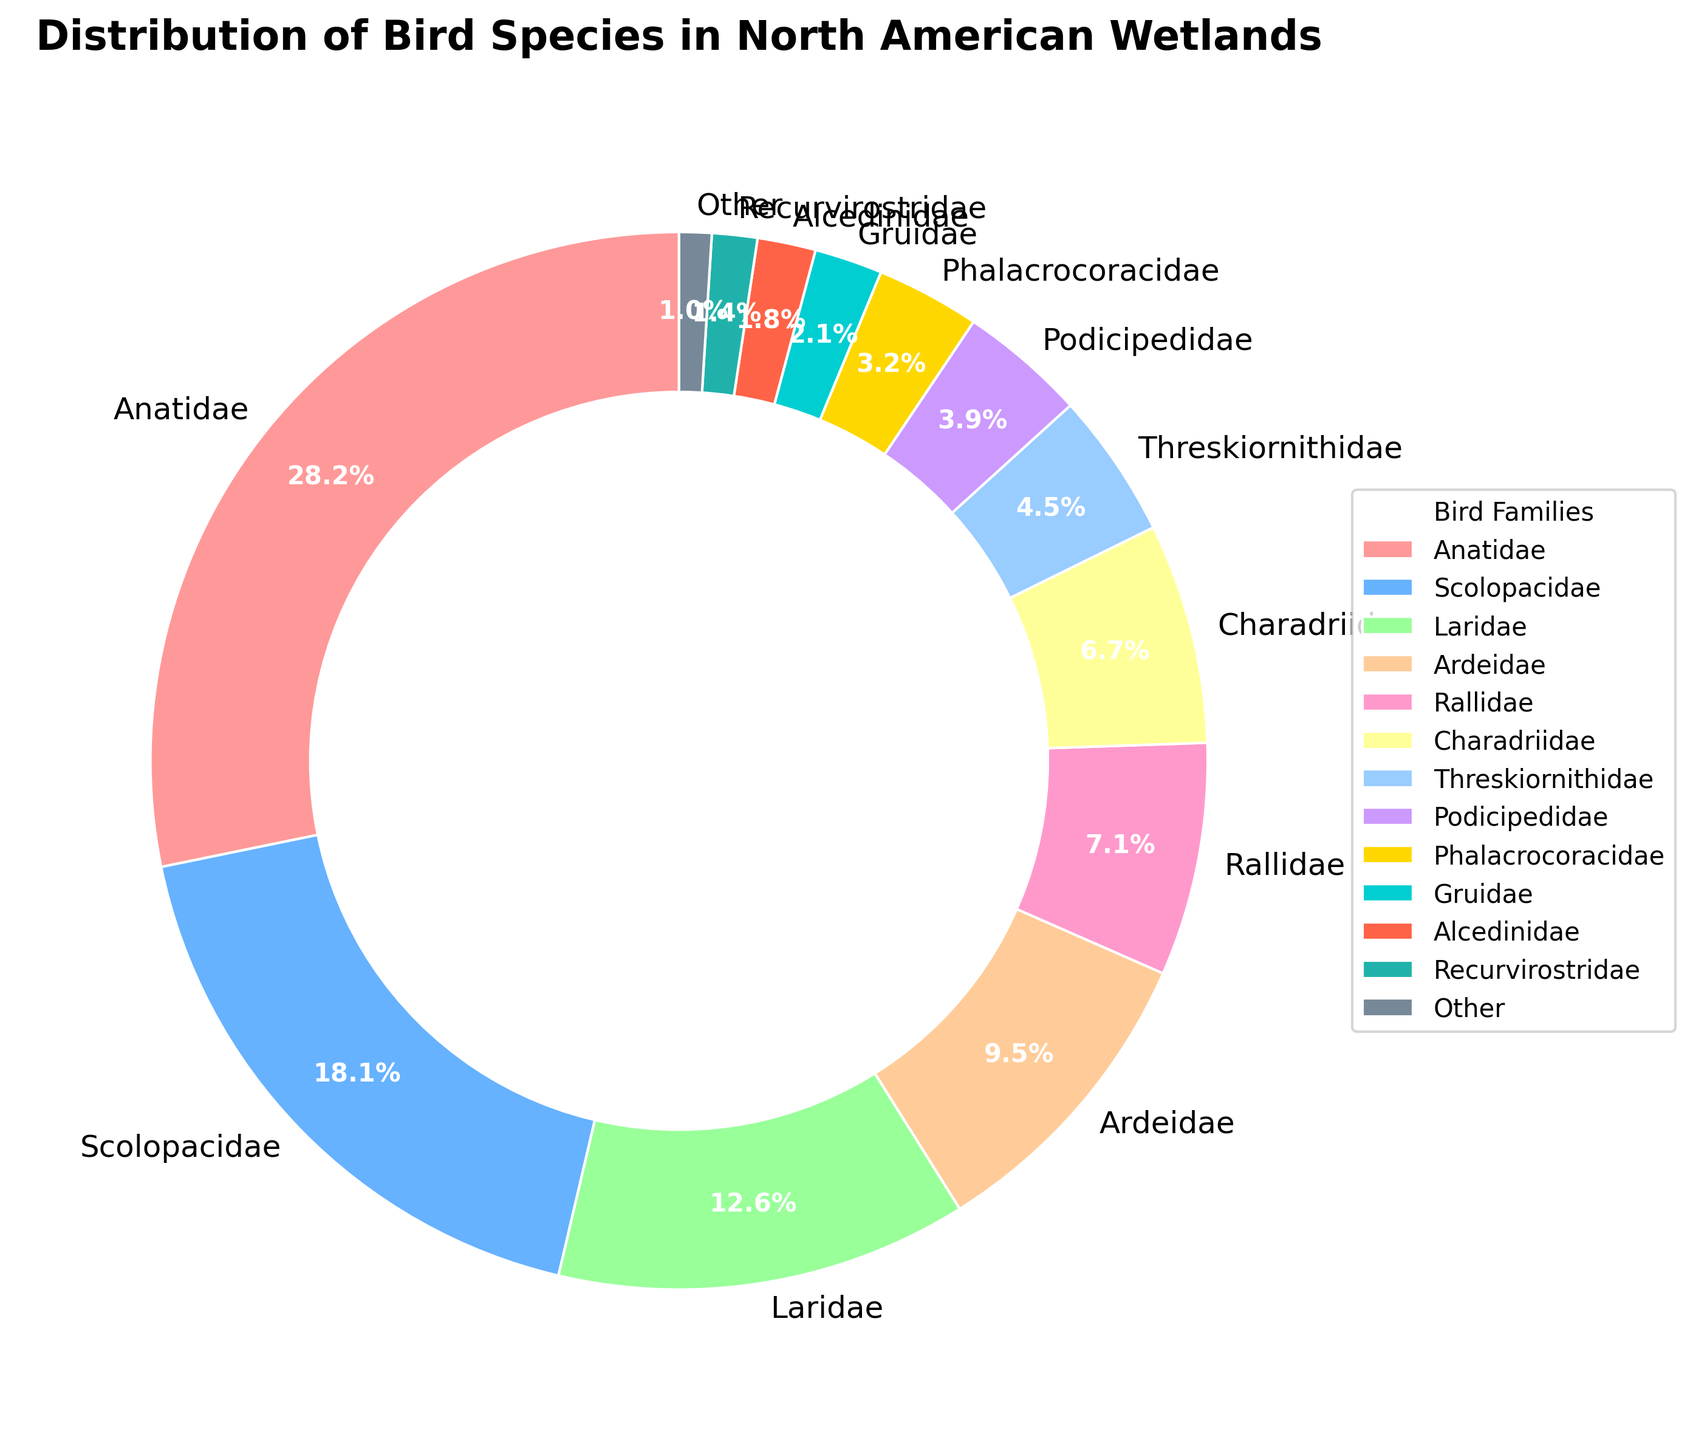What's the largest family of bird species in North American wetlands based on the chart? The chart shows various families and their respective percentages. The family with the highest percentage represents the largest family. The Anatidae family has the highest value of 28.5%.
Answer: Anatidae What's the combined percentage of bird species for the Ardeidae and Rallidae families? The chart lists the percentages for Ardeidae and Rallidae as 9.6% and 7.2%, respectively. Adding these percentages together gives a total of 9.6% + 7.2% = 16.8%.
Answer: 16.8% Which family has a higher percentage of bird species: Charadriidae or Threskiornithidae? The chart shows the percentage for Charadriidae as 6.8% and for Threskiornithidae as 4.5%. Comparing these values, 6.8% (Charadriidae) is greater than 4.5% (Threskiornithidae).
Answer: Charadriidae What is the total percentage of bird species contributed by families with less than 5% each? The families with less than 5% are Threskiornithidae (4.5%), Podicipedidae (3.9%), Phalacrocoracidae (3.2%), Gruidae (2.1%), Alcedinidae (1.8%), Recurvirostridae (1.4%), and Other (1.0%). Adding these percentages together: 4.5% + 3.9% + 3.2% + 2.1% + 1.8% + 1.4% + 1.0% = 17.9%.
Answer: 17.9% Is there a family of bird species in the wetlands represented by the color red on the chart, and if so, which one is it? Upon examining the chart, the wedges are colored, and we see that the wedge colored red represents the Anatidae family.
Answer: Anatidae How many times larger is the percentage of Anatidae compared to the percentage of Gruidae? The percentage of Anatidae is 28.5% and the percentage of Gruidae is 2.1%. To find out how many times larger, divide 28.5 by 2.1, it equals approximately 13.57.
Answer: 13.57 Which two families have the closest percentages and what are those percentages? By examining the percentages in the chart, the two closest percentages are Rallidae (7.2%) and Charadriidae (6.8%) with a difference of only 0.4%.
Answer: Rallidae (7.2%) and Charadriidae (6.8%) What family has the smallest representation in the wetlands and what is its percentage? The chart shows the "Other" category with the smallest percentage at 1.0%.
Answer: Other If Laridae and Alcedinidae are combined into a single category, what would their total percentage be? The chart lists the percentages for Laridae as 12.7% and Alcedinidae as 1.8%. Adding these percentages together gives 12.7% + 1.8% = 14.5%.
Answer: 14.5% 